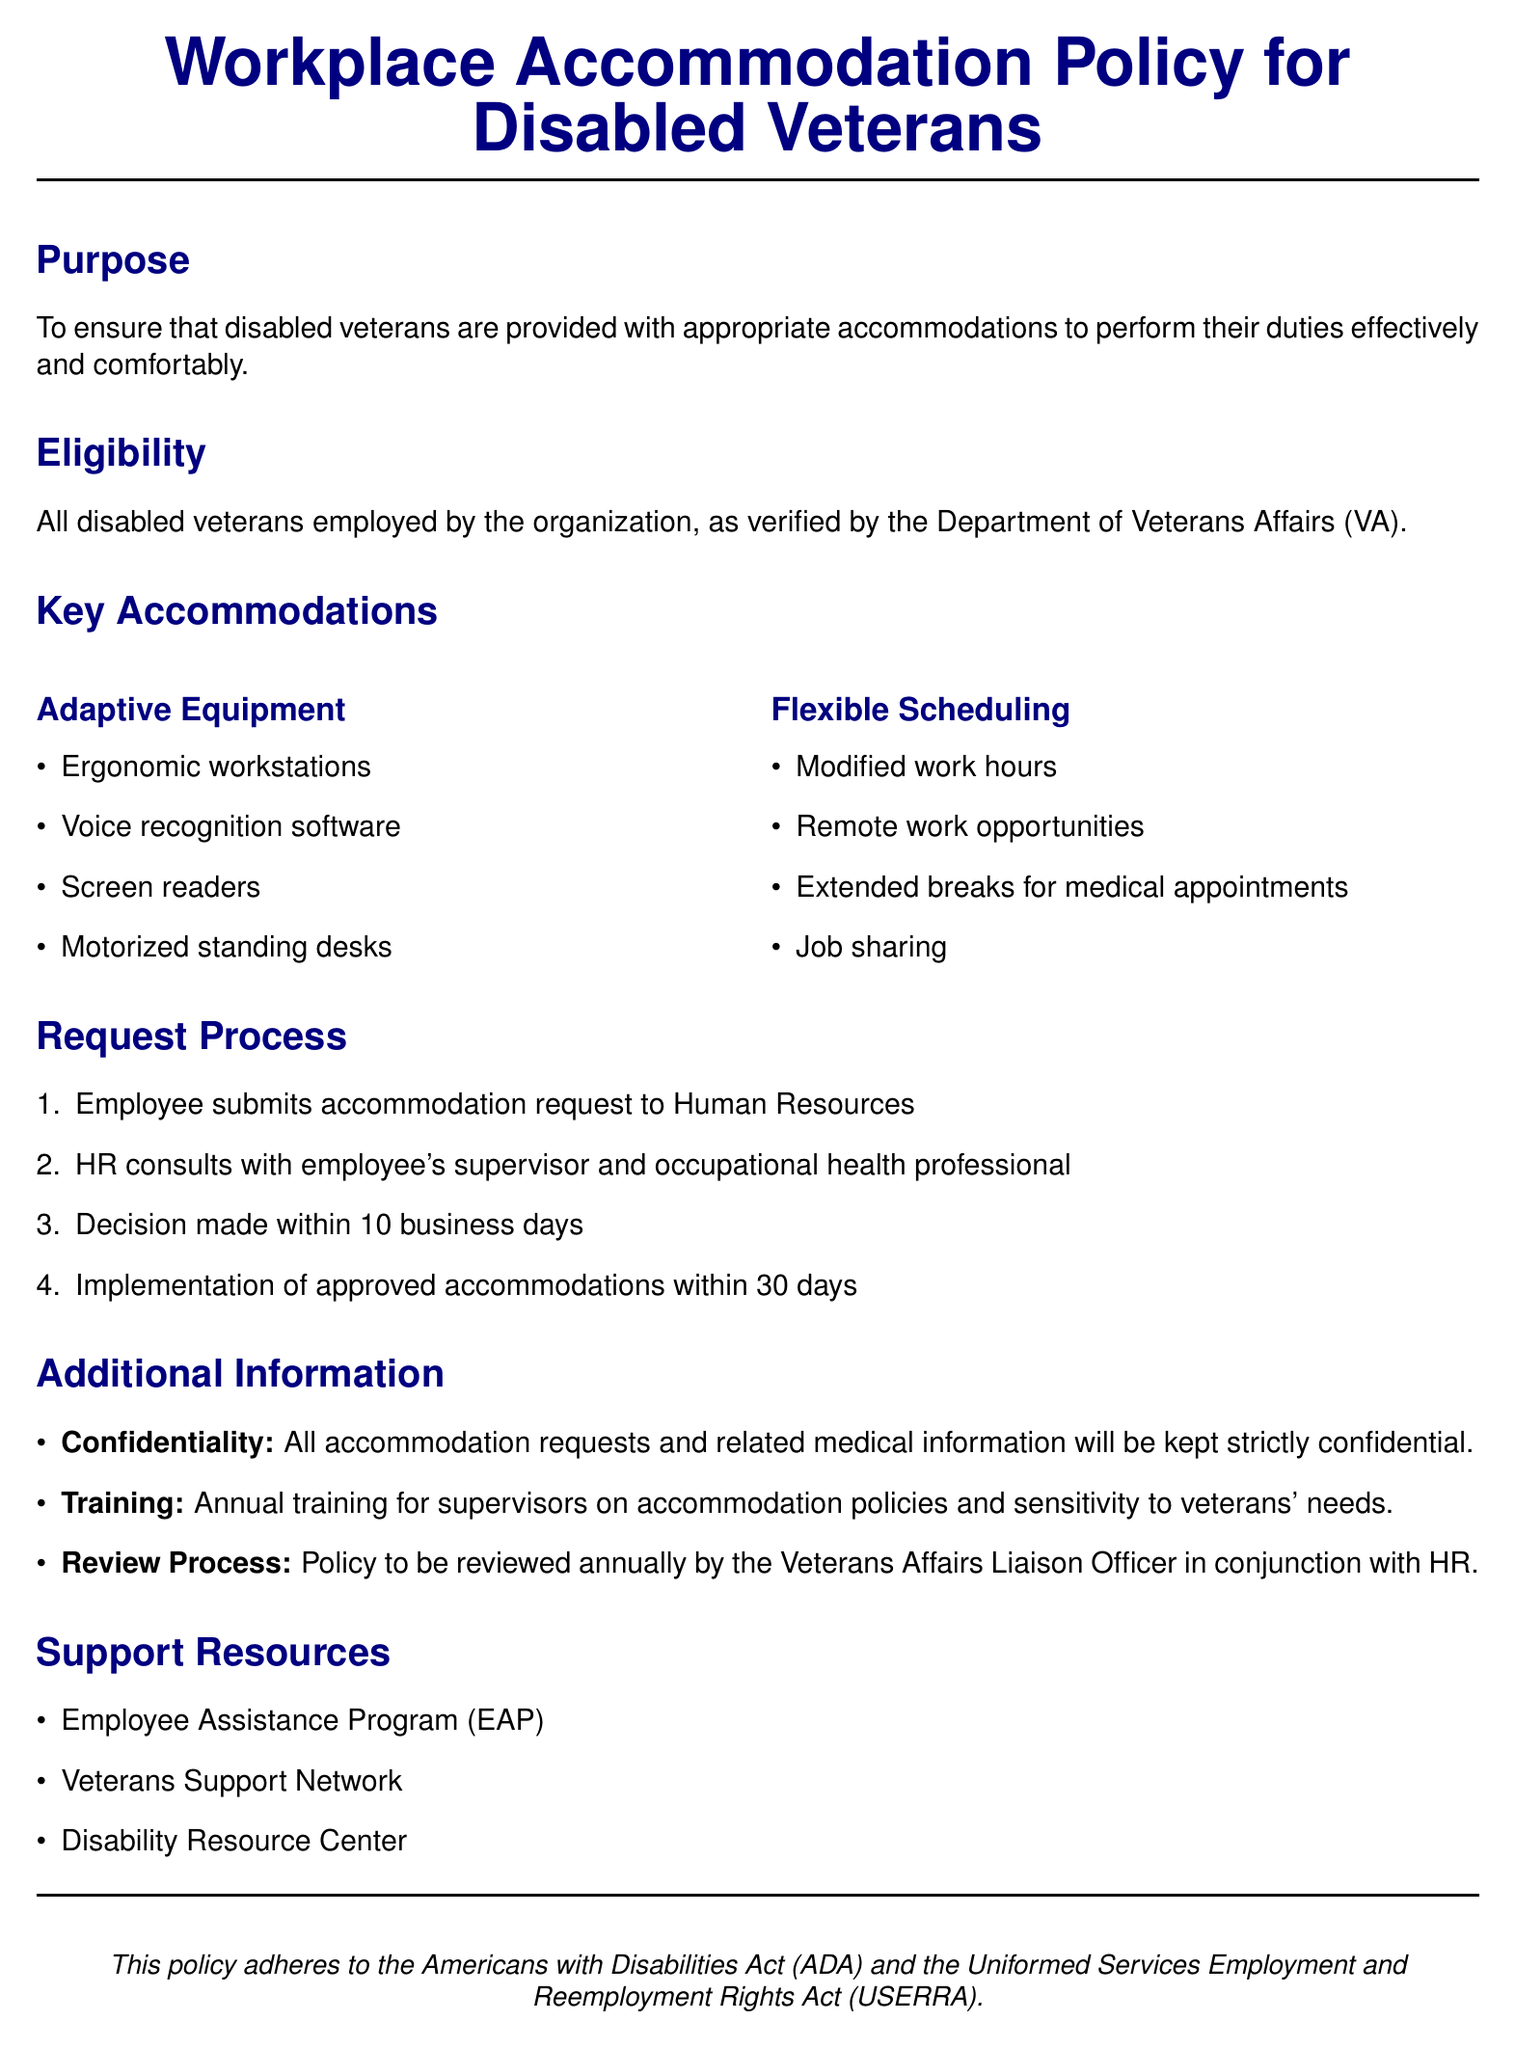What is the purpose of the policy? The purpose of the policy is to ensure that disabled veterans are provided with appropriate accommodations to perform their duties effectively and comfortably.
Answer: To ensure that disabled veterans are provided with appropriate accommodations to perform their duties effectively and comfortably Who verifies the eligibility for accommodations? The eligibility for accommodations is verified by the Department of Veterans Affairs.
Answer: Department of Veterans Affairs What is one type of adaptive equipment listed? One example of adaptive equipment listed in the document is motorized standing desks.
Answer: Motorized standing desks How long does HR have to make a decision on an accommodation request? HR has a timeline of 10 business days to make a decision on an accommodation request.
Answer: 10 business days What kind of training is mentioned in the policy? The policy mentions that supervisors will receive annual training on accommodation policies.
Answer: Annual training for supervisors What is the confidentiality policy regarding accommodation requests? The policy states that all accommodation requests and related medical information will be kept strictly confidential.
Answer: Strictly confidential What is one support resource provided to veterans? One of the support resources provided is the Employee Assistance Program.
Answer: Employee Assistance Program How often will the policy be reviewed? The policy is to be reviewed annually.
Answer: Annually 